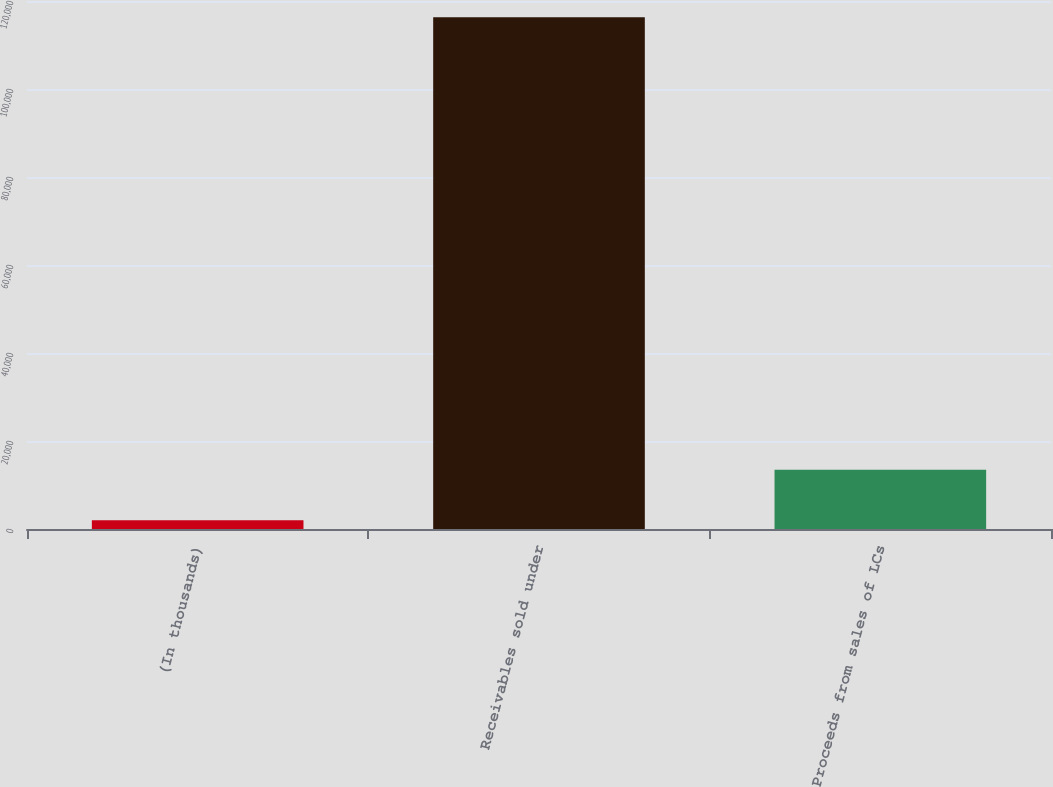Convert chart. <chart><loc_0><loc_0><loc_500><loc_500><bar_chart><fcel>(In thousands)<fcel>Receivables sold under<fcel>Proceeds from sales of LCs<nl><fcel>2014<fcel>116292<fcel>13441.8<nl></chart> 